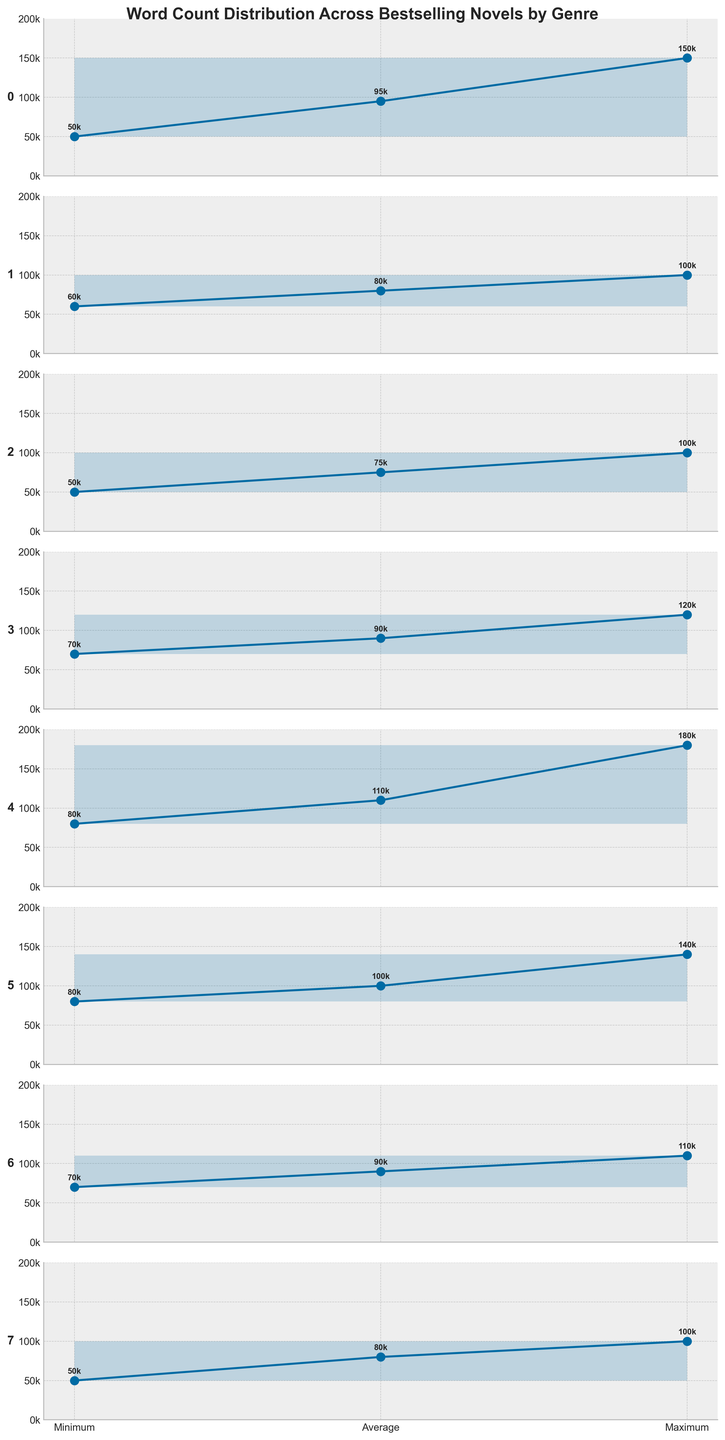How many genres are shown in the plot? Each genre has its own subplot, there are a total of 8 subplots indicating there are 8 genres in the plot.
Answer: 8 What's the title of the figure? The title is written at the top of the figure in bold font. It reads: "Word Count Distribution Across Bestselling Novels by Genre".
Answer: Word Count Distribution Across Bestselling Novels by Genre Which genre has the highest maximum word count? By looking at the maximum word count values across all genres, Fantasy has the highest maximum word count value of 180,000.
Answer: Fantasy What is the minimum word count for Science Fiction novels? By finding the subplot labeled "Science Fiction" and looking at the annotation near the minimum marker, it shows a value of 70k.
Answer: 70,000 Compare the average word counts of Literary Fiction and Fantasy. Which one is higher and by how much? Literary Fiction's average word count is 95,000 and Fantasy's average word count is 110,000, so Fantasy's average word count is higher by 15,000 words.
Answer: Fantasy by 15,000 words Which genre has the smallest range between its minimum and maximum word counts? We need to compare the range (maximum - minimum) for each genre. Mystery has a range of (100,000 - 60,000) = 40,000, which is the smallest range among all.
Answer: Mystery What is the word count range for Historical Fiction novels? The minimum word count for Historical Fiction is 80,000 and the maximum is 140,000. The range is calculated as 140,000 - 80,000 = 60,000.
Answer: 60,000 Does Thriller have a higher average word count than Romance? The subplot for Thriller shows an average word count of 90k, while Romance shows an average of 75k. Therefore, Thriller has a higher average word count.
Answer: Yes How does the maximum word count of Horror compare to that of Mystery? The maximum word count for both Horror and Mystery novels is 100k, so they are equal.
Answer: Equal What is the difference between the maximum word counts of Fantasy and Historical Fiction? The maximum word count for Fantasy is 180k and for Historical Fiction is 140k. The difference is calculated as 180,000 - 140,000 = 40,000.
Answer: 40,000 